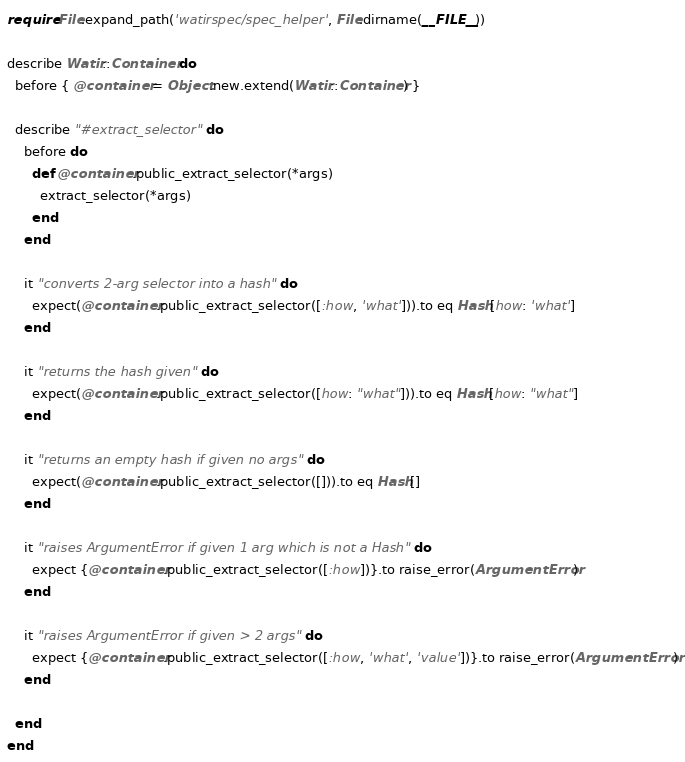Convert code to text. <code><loc_0><loc_0><loc_500><loc_500><_Ruby_>require File.expand_path('watirspec/spec_helper', File.dirname(__FILE__))

describe Watir::Container do
  before { @container = Object.new.extend(Watir::Container) }

  describe "#extract_selector" do
    before do
      def @container.public_extract_selector(*args)
        extract_selector(*args)
      end
    end

    it "converts 2-arg selector into a hash" do
      expect(@container.public_extract_selector([:how, 'what'])).to eq Hash[how: 'what']
    end

    it "returns the hash given" do
      expect(@container.public_extract_selector([how: "what"])).to eq Hash[how: "what"]
    end

    it "returns an empty hash if given no args" do
      expect(@container.public_extract_selector([])).to eq Hash[]
    end

    it "raises ArgumentError if given 1 arg which is not a Hash" do
      expect {@container.public_extract_selector([:how])}.to raise_error(ArgumentError)
    end

    it "raises ArgumentError if given > 2 args" do
      expect {@container.public_extract_selector([:how, 'what', 'value'])}.to raise_error(ArgumentError)
    end

  end
end
</code> 